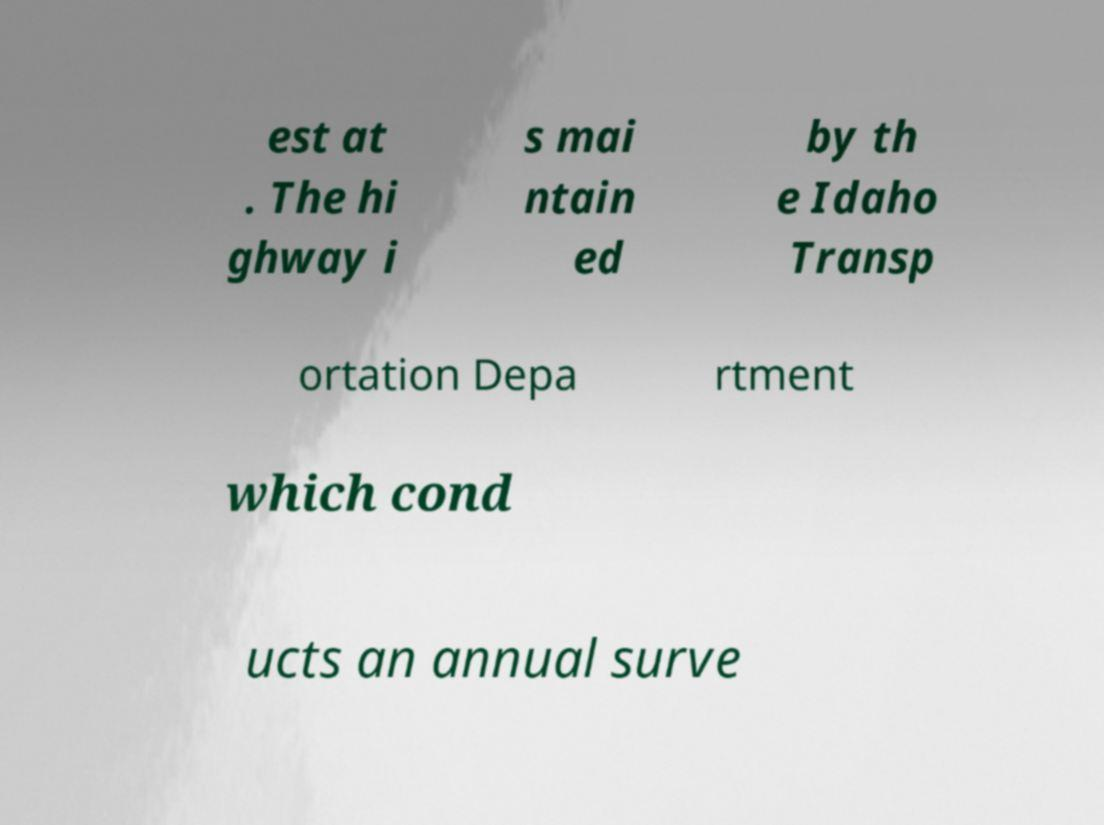Could you extract and type out the text from this image? est at . The hi ghway i s mai ntain ed by th e Idaho Transp ortation Depa rtment which cond ucts an annual surve 